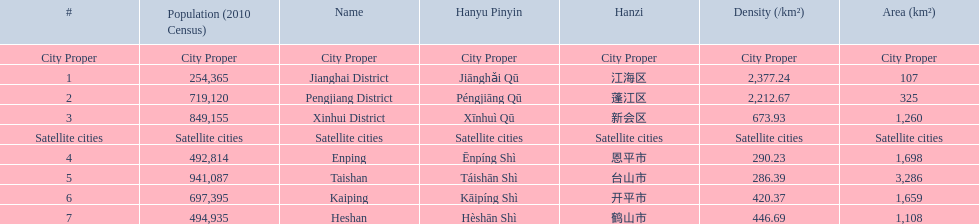What city propers are listed? Jianghai District, Pengjiang District, Xinhui District. Which hast he smallest area in km2? Jianghai District. 